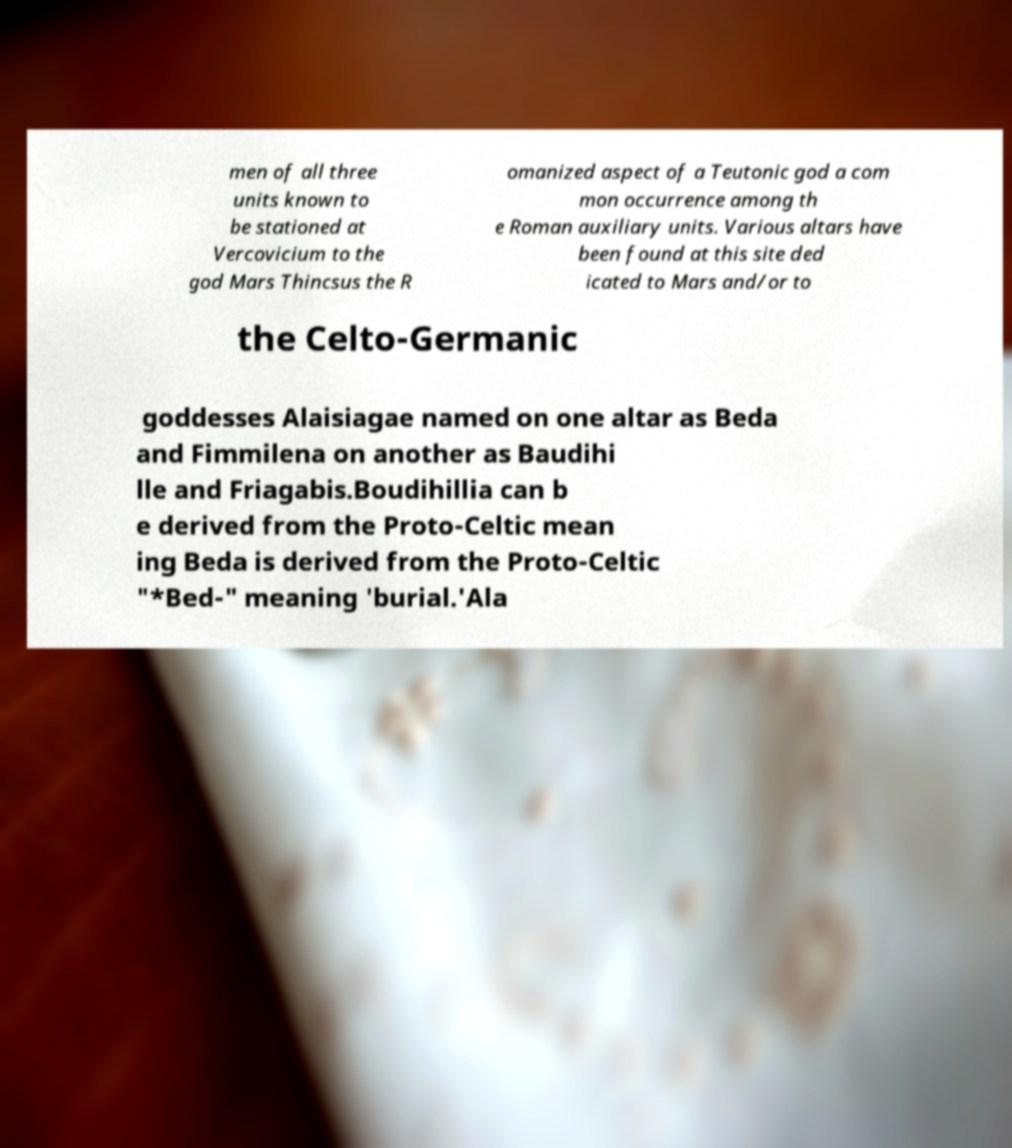What messages or text are displayed in this image? I need them in a readable, typed format. men of all three units known to be stationed at Vercovicium to the god Mars Thincsus the R omanized aspect of a Teutonic god a com mon occurrence among th e Roman auxiliary units. Various altars have been found at this site ded icated to Mars and/or to the Celto-Germanic goddesses Alaisiagae named on one altar as Beda and Fimmilena on another as Baudihi lle and Friagabis.Boudihillia can b e derived from the Proto-Celtic mean ing Beda is derived from the Proto-Celtic "*Bed-" meaning 'burial.'Ala 